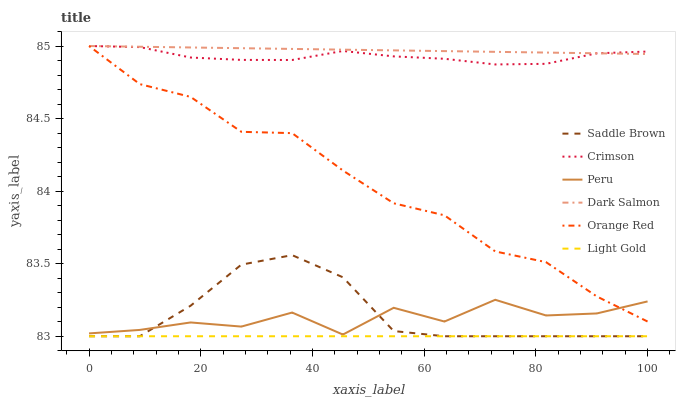Does Light Gold have the minimum area under the curve?
Answer yes or no. Yes. Does Dark Salmon have the maximum area under the curve?
Answer yes or no. Yes. Does Saddle Brown have the minimum area under the curve?
Answer yes or no. No. Does Saddle Brown have the maximum area under the curve?
Answer yes or no. No. Is Light Gold the smoothest?
Answer yes or no. Yes. Is Peru the roughest?
Answer yes or no. Yes. Is Saddle Brown the smoothest?
Answer yes or no. No. Is Saddle Brown the roughest?
Answer yes or no. No. Does Peru have the lowest value?
Answer yes or no. No. Does Orange Red have the highest value?
Answer yes or no. Yes. Does Saddle Brown have the highest value?
Answer yes or no. No. Is Light Gold less than Dark Salmon?
Answer yes or no. Yes. Is Orange Red greater than Light Gold?
Answer yes or no. Yes. Does Saddle Brown intersect Light Gold?
Answer yes or no. Yes. Is Saddle Brown less than Light Gold?
Answer yes or no. No. Is Saddle Brown greater than Light Gold?
Answer yes or no. No. Does Light Gold intersect Dark Salmon?
Answer yes or no. No. 